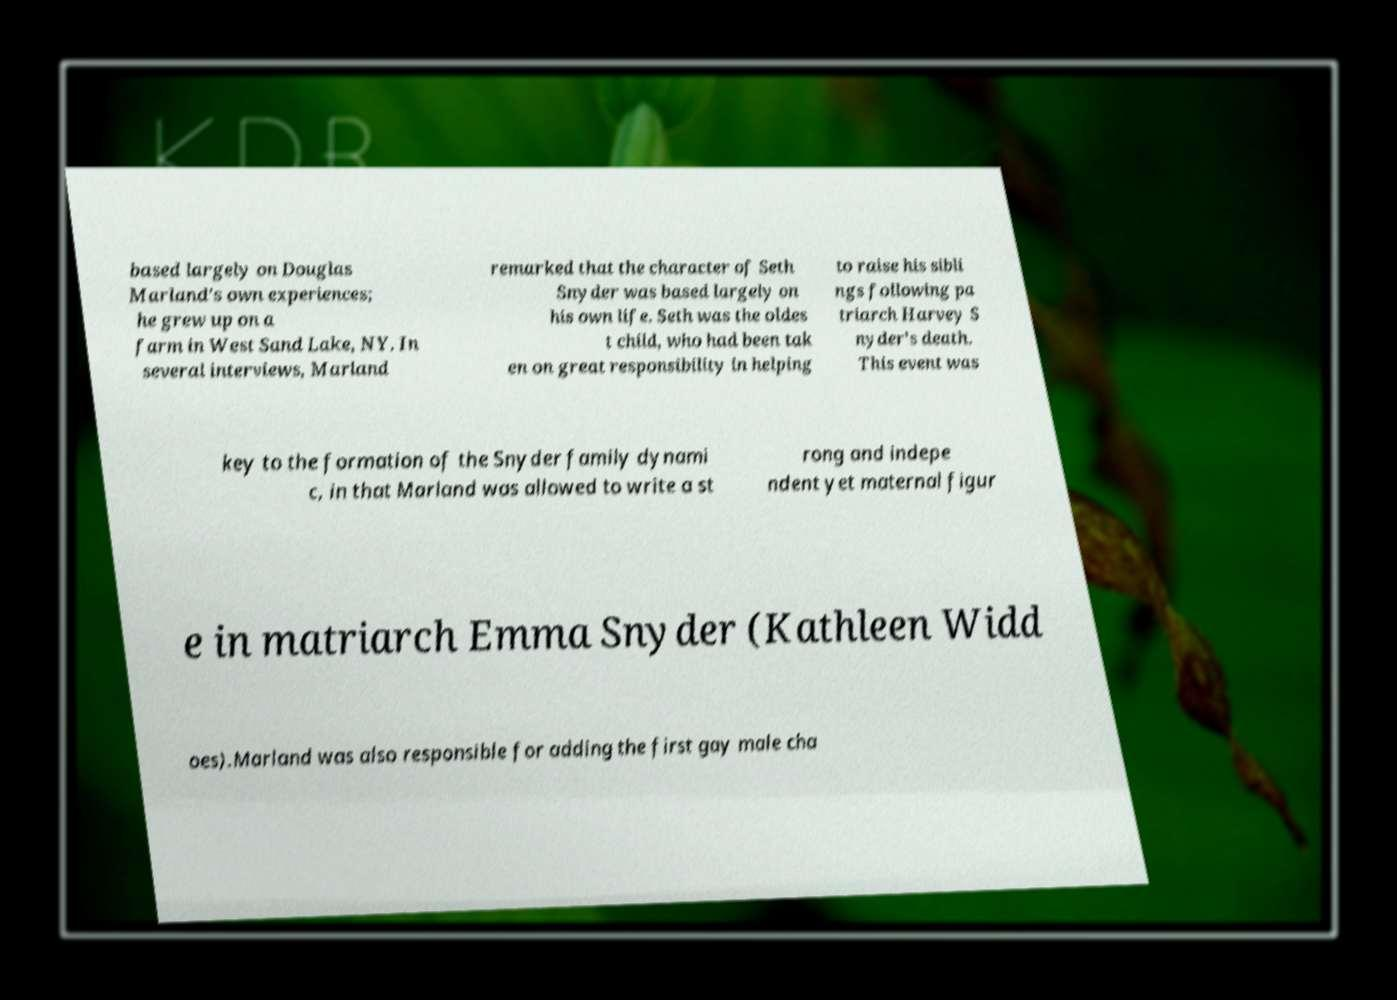Please identify and transcribe the text found in this image. based largely on Douglas Marland's own experiences; he grew up on a farm in West Sand Lake, NY. In several interviews, Marland remarked that the character of Seth Snyder was based largely on his own life. Seth was the oldes t child, who had been tak en on great responsibility in helping to raise his sibli ngs following pa triarch Harvey S nyder's death. This event was key to the formation of the Snyder family dynami c, in that Marland was allowed to write a st rong and indepe ndent yet maternal figur e in matriarch Emma Snyder (Kathleen Widd oes).Marland was also responsible for adding the first gay male cha 